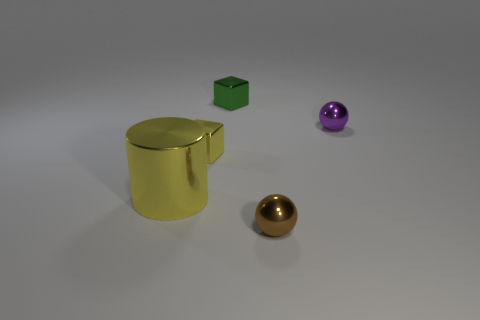Add 1 small green shiny blocks. How many objects exist? 6 Subtract all yellow cubes. How many cubes are left? 1 Subtract all yellow cylinders. How many yellow cubes are left? 1 Subtract 2 spheres. How many spheres are left? 0 Subtract all tiny green shiny objects. Subtract all large yellow cylinders. How many objects are left? 3 Add 2 green things. How many green things are left? 3 Add 3 green objects. How many green objects exist? 4 Subtract 0 cyan cylinders. How many objects are left? 5 Subtract all cubes. How many objects are left? 3 Subtract all cyan cylinders. Subtract all green blocks. How many cylinders are left? 1 